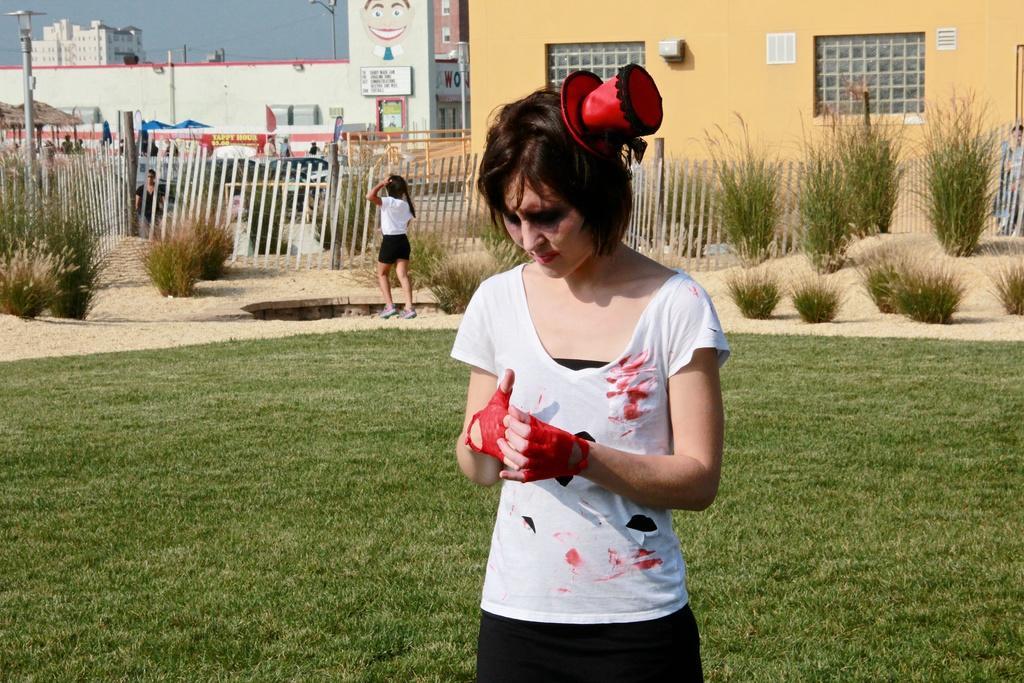How would you summarize this image in a sentence or two? In this image there are people. At the bottom there is grass and we can see plants and there are buildings. We can see poles. At the top there is sky and we can see a fence. 